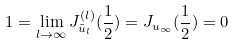<formula> <loc_0><loc_0><loc_500><loc_500>1 = \lim _ { l \rightarrow \infty } J _ { \tilde { u } _ { l } } ^ { ( l ) } ( \frac { 1 } { 2 } ) = J _ { u _ { \infty } } ( \frac { 1 } { 2 } ) = 0</formula> 